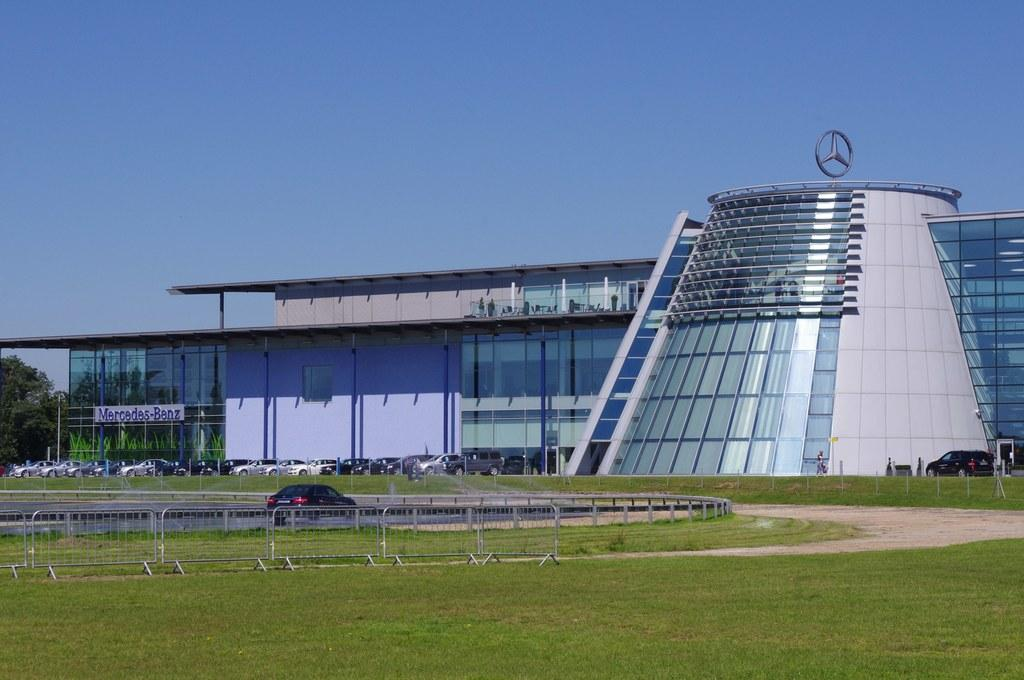What type of barrier can be seen in the image? There is a fence in the image. What type of terrain is visible at the bottom of the image? There is a grassy land at the bottom of the image. What type of structure is present in the image? There is a building in the image. What type of vegetation can be seen in the image? There are trees in the image. What type of vehicles are present in the image? There are cars in the image. What is visible in the background of the image? The sky is visible in the background of the image. What is the purpose of the match in the image? There is no match present in the image. What type of journey is depicted in the image? There is no journey depicted in the image; it features a fence, grassy land, a building, trees, cars, and the sky. 